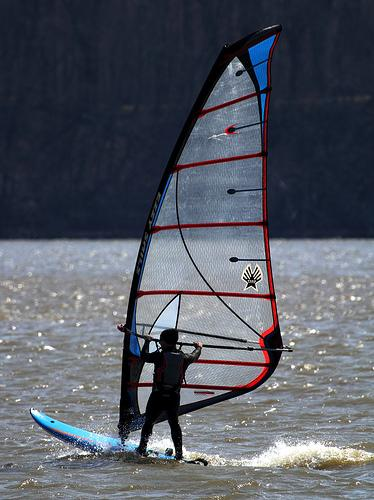Provide an analysis of the image's sentiment or emotion. The image conveys a sense of adventure and excitement, as the man is windsurfing with determination amidst the splashing waves and shining water. What is the state of the water in the image? Describe the color and associated actions. The water is greenish-blue and grayish-brown with light glistening and sun shining on it. Waves are splashing and spraying up, creating white water bubbles. What are some visible elements of the surrounding environment? There is a dark wall of mountain in the background, and light is glistening on the greenish-blue and grayish-brown water. Describe the color scheme and design of the sail in the image. The sail has a black, red, blue, and clear color scheme with black lines at the sides and a curved black line over its width. Discuss the physical appearance and the action performed by the man in the image. The man is in silhouette, wearing a black wet suit and holding onto a bar with both hands while standing on a blue surfboard with a red stripe. Count the total number of objects mentioned in the image description and provide a description of each. There are 6 objects: a windsurfer, a transparent sail, a blue surfboard with red stripe, a black-red-blue-bordered sail, a curved pole holding up the sail, and a churning water behind the surfboard. Provide a detailed description of the surfboard in the image. The surfboard is blue with a red stripe, and it has a black and white decal towards its tail end. What is the man wearing on his body and head, and what color are those items? The man is wearing a black wet suit and a black cap on his head. Identify the sport being portrayed in the image. The sport in the image is windsurfing. Describe any possible interactions between the main subject and his equipment. The windsurfer is holding onto a bar attached to the sail and standing on the surfboard, maintaining balance and control in the water. What kind of object is the person holding with both hands? The person is holding a bar. What is happening to the water behind the surfboard? Water is churning and spraying up, with white water bubbling up. Is the person windsurfing in a calm or turbulent body of water? Turbulent, with waves splashing and water churning. Describe the mountain feature in the background. A dark wall of a mountain. Identify the sport being performed in this image. Windsurfing. Is the person's silhouette visible in this image? Yes, the person is in silhouette. Which part of the windsail is visible in the image? The tip of a windsail. What is on the surfer's head? A black cap. In the image, what is the sun's effect on the water? The sun is glistening and shining on the water. List the primary colors present on the windsurf sail. Black, red, and blue. Identify presence of any anomalies in the image. No anomalies detected. What color is the trim on the sail of the windsurfer? Red. What is the color of the surfboard the person is standing on? Blue with a red stripe. What color is the water in the image? Greenish-blue and grayish-brown. Assess the quality of this image and explain your reasoning. The image quality is high because it has clear details and multiple easily identifiable objects with different attributes. Can you see a dog on the surfboard with the surfer? There is no mention of a dog in the image information, so this instruction falsely suggests that there might be an animal present. Is the surfer wearing a bright orange wetsuit? The surfer is actually wearing a black wetsuit, so this instruction is misleading by suggesting a different color for the clothing. Is the water a bright turquoise color? The actual color of the water mentioned in the image is greenish-blue and grayish-brown, not bright turquoise, which could lead someone to misinterpret the color of the water in the image. Is there a logo or decal present in the image? If so, what are its color attributes? Yes, a black and white decal is present. Describe the image with the windsurfer. A person is windsurfing on greenish-blue water with a transparent sail that has black, red, and blue borders. The surfer is wearing a black wetsuit and holding onto a bar, standing on a blue surfboard with a red stripe. Is the center of the sail transparent or opaque? The center of the sail is clear (transparent). Determine the sentiment portrayed by this windsurfing image. Exciting and adventurous. Is the windsurfer holding a pink umbrella instead of a transparent sail? The windsurfer is actually holding a transparent sail, not a pink umbrella, so this instruction misleads the reader into thinking there's an umbrella involved. What type of suit is the person wearing? A black wetsuit. Is there a yellow surfboard with green stripes in the image? The actual surfboard in the image is blue with a red stripe, but by describing one with entirely different colors, it may lead others to incorrectly identify the object. Are there pink flamingos visible in the background near the dark mountain wall? There are no pink flamingos or any other bird mentioned in the image information, so this instruction erroneously introduces an unrelated element to the scene. 